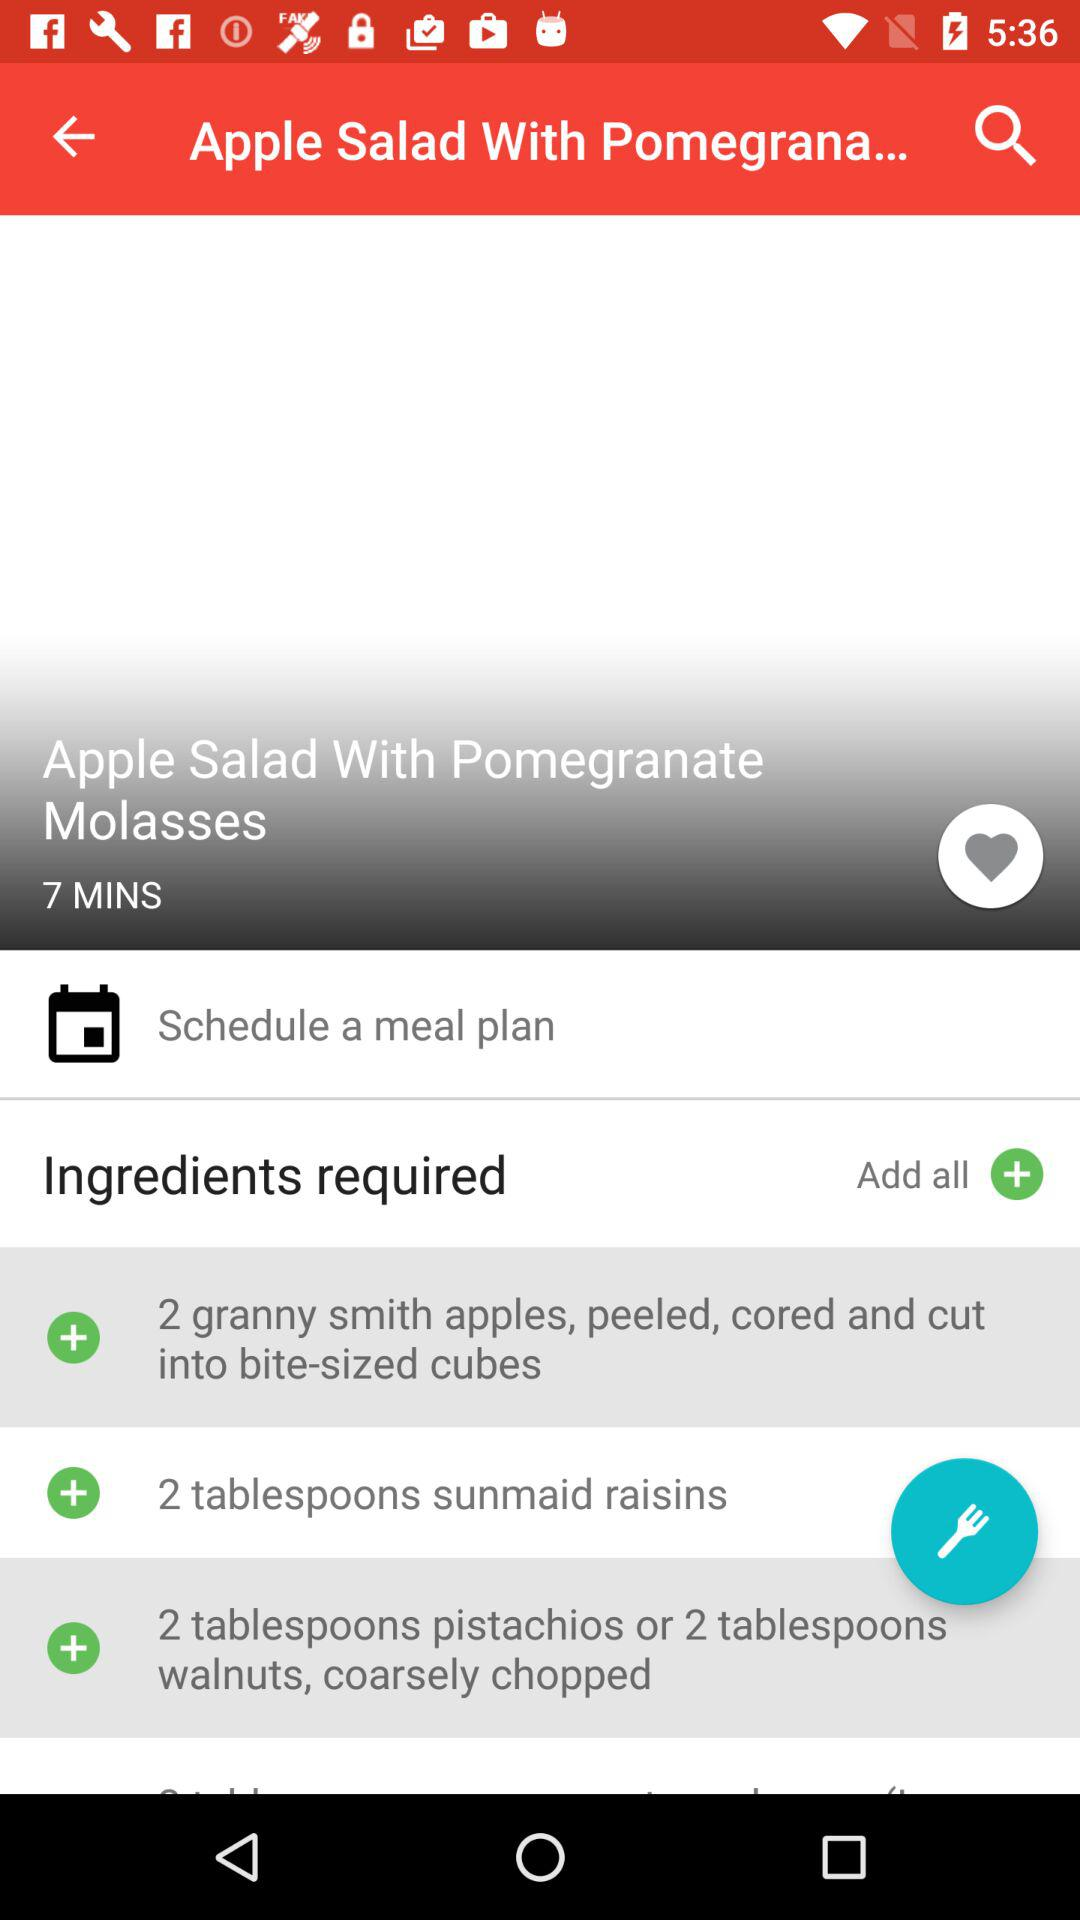What is the name of the recipe? The name of the recipe is Apple Salad With Pomegranate Molasses. 